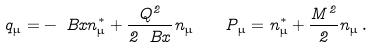Convert formula to latex. <formula><loc_0><loc_0><loc_500><loc_500>q _ { \mu } = - \ B x n ^ { \ast } _ { \mu } + \frac { Q ^ { 2 } } { 2 \ B x } n _ { \mu } \, \quad P _ { \mu } = n ^ { \ast } _ { \mu } + \frac { M ^ { 2 } } { 2 } n _ { \mu } \, .</formula> 